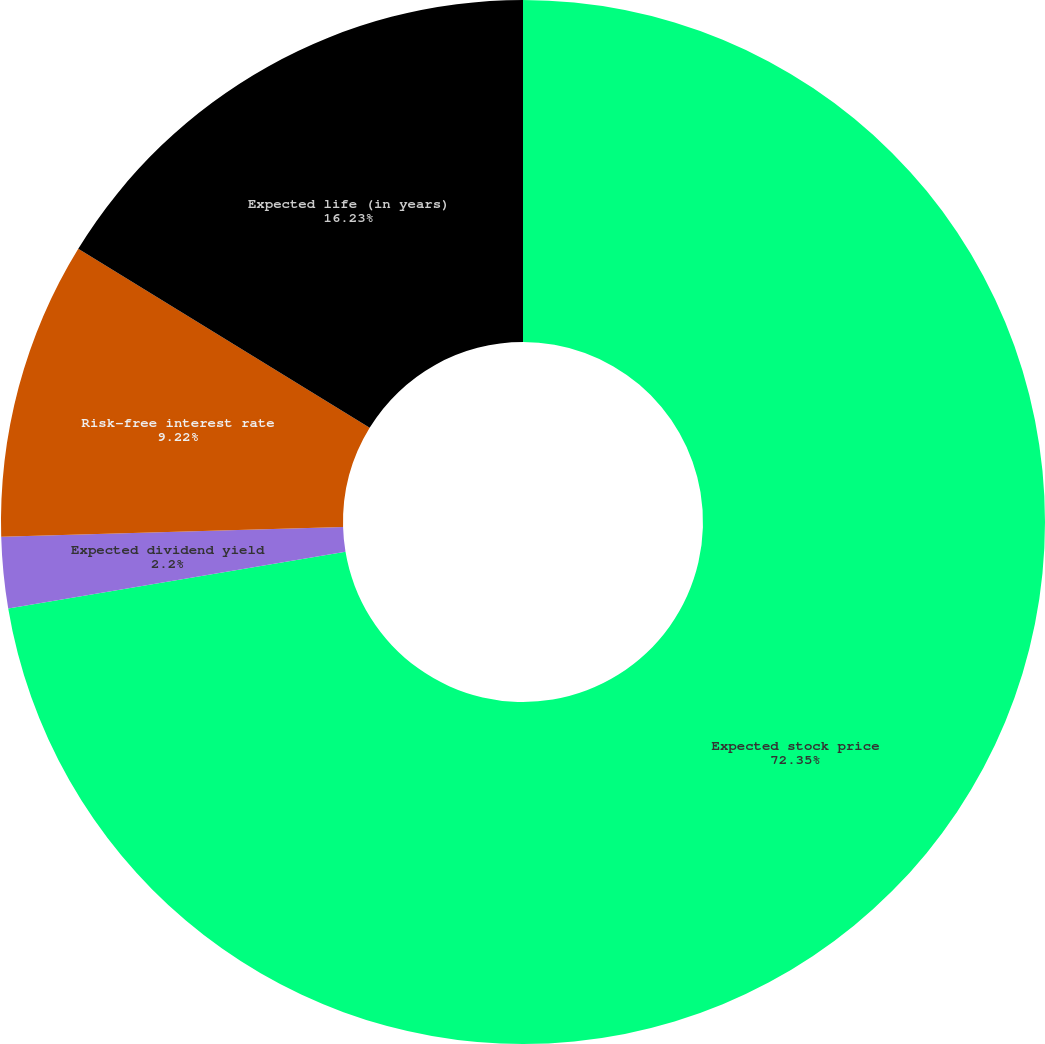Convert chart. <chart><loc_0><loc_0><loc_500><loc_500><pie_chart><fcel>Expected stock price<fcel>Expected dividend yield<fcel>Risk-free interest rate<fcel>Expected life (in years)<nl><fcel>72.35%<fcel>2.2%<fcel>9.22%<fcel>16.23%<nl></chart> 